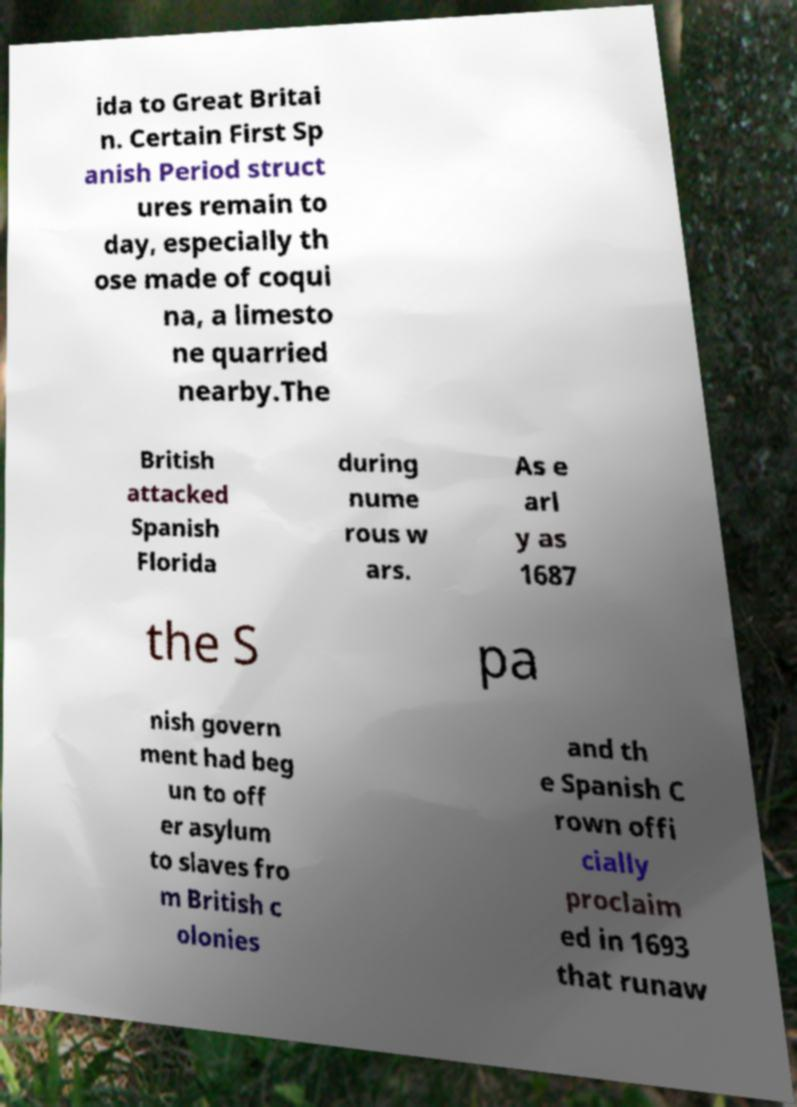Can you read and provide the text displayed in the image?This photo seems to have some interesting text. Can you extract and type it out for me? ida to Great Britai n. Certain First Sp anish Period struct ures remain to day, especially th ose made of coqui na, a limesto ne quarried nearby.The British attacked Spanish Florida during nume rous w ars. As e arl y as 1687 the S pa nish govern ment had beg un to off er asylum to slaves fro m British c olonies and th e Spanish C rown offi cially proclaim ed in 1693 that runaw 